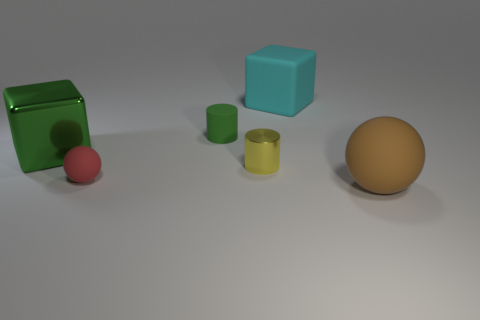There is a object that is the same color as the shiny block; what is its shape?
Offer a terse response. Cylinder. What number of things are to the left of the tiny sphere and on the right side of the rubber block?
Make the answer very short. 0. What is the shape of the tiny green thing that is made of the same material as the red object?
Offer a very short reply. Cylinder. There is a ball left of the tiny yellow metallic cylinder; is it the same size as the metallic object that is on the left side of the yellow metallic cylinder?
Make the answer very short. No. What is the color of the matte ball that is on the left side of the big brown rubber object?
Give a very brief answer. Red. There is a tiny cylinder in front of the green thing right of the green block; what is it made of?
Provide a succinct answer. Metal. What is the shape of the small yellow thing?
Keep it short and to the point. Cylinder. What is the material of the brown object that is the same shape as the tiny red matte thing?
Offer a very short reply. Rubber. What number of green matte cylinders are the same size as the yellow thing?
Your answer should be compact. 1. There is a cube that is in front of the large cyan thing; is there a block that is right of it?
Keep it short and to the point. Yes. 